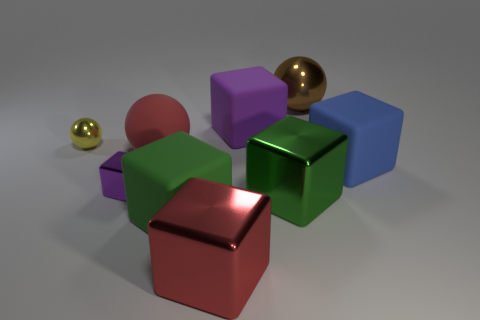How many green blocks must be subtracted to get 1 green blocks? 1 Add 1 big yellow cylinders. How many objects exist? 10 Subtract all big spheres. How many spheres are left? 1 Subtract all purple blocks. How many blocks are left? 4 Subtract 4 blocks. How many blocks are left? 2 Subtract all balls. How many objects are left? 6 Subtract all cyan spheres. Subtract all red blocks. How many spheres are left? 3 Subtract all cyan spheres. How many blue cubes are left? 1 Subtract all red spheres. Subtract all green blocks. How many objects are left? 6 Add 6 red metal objects. How many red metal objects are left? 7 